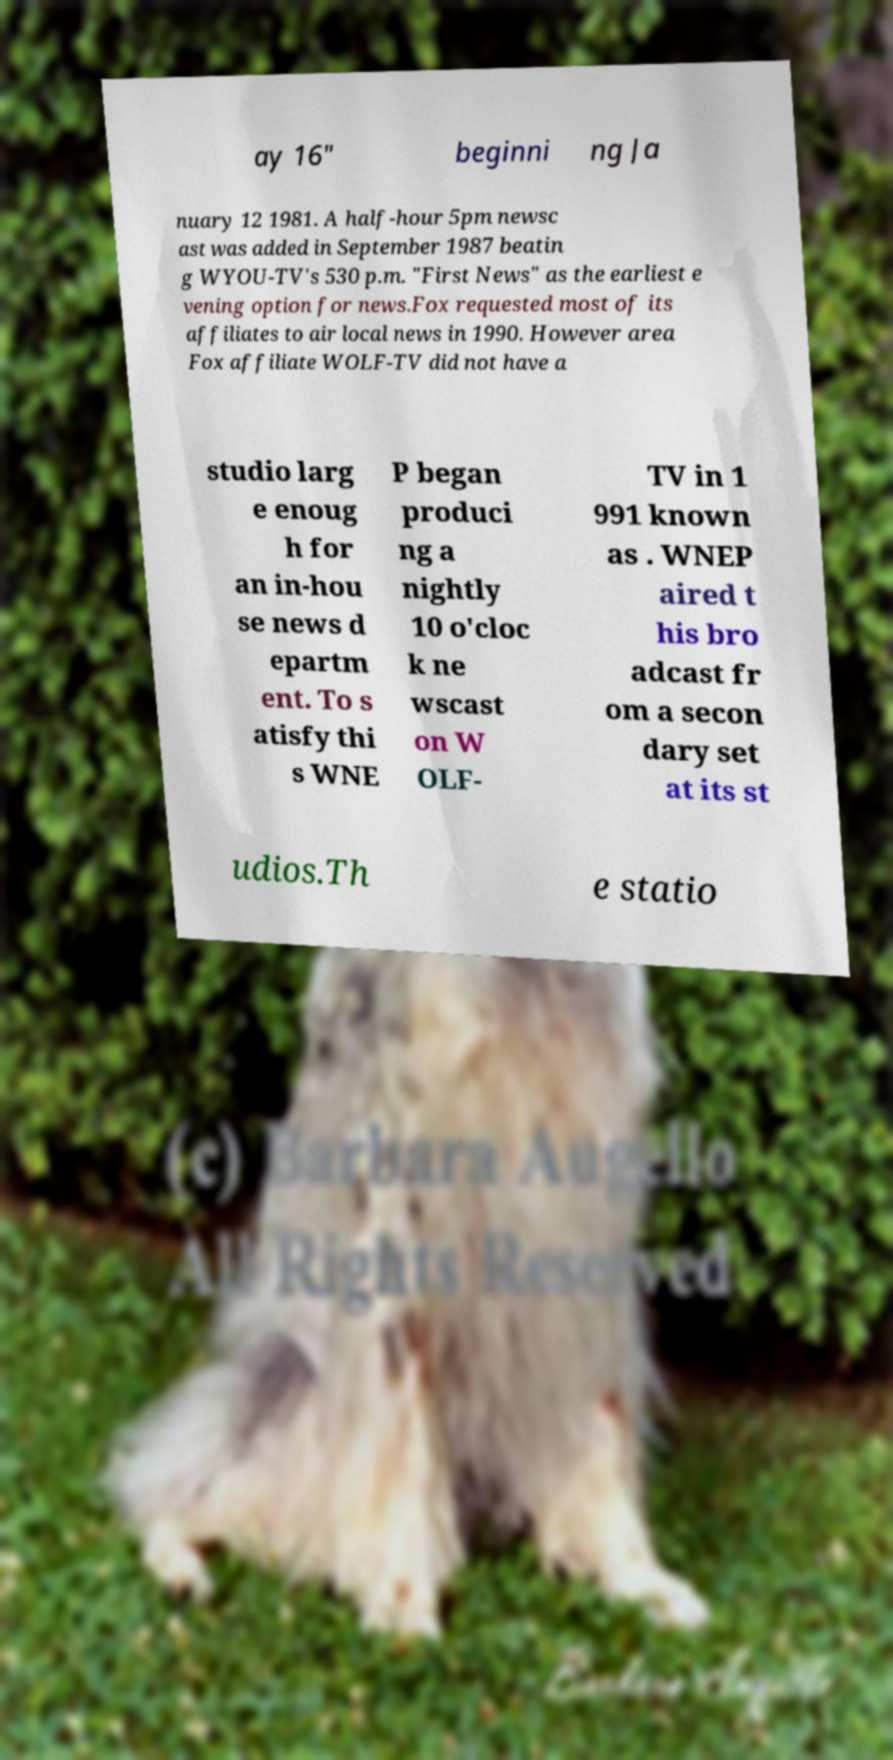For documentation purposes, I need the text within this image transcribed. Could you provide that? ay 16" beginni ng Ja nuary 12 1981. A half-hour 5pm newsc ast was added in September 1987 beatin g WYOU-TV's 530 p.m. "First News" as the earliest e vening option for news.Fox requested most of its affiliates to air local news in 1990. However area Fox affiliate WOLF-TV did not have a studio larg e enoug h for an in-hou se news d epartm ent. To s atisfy thi s WNE P began produci ng a nightly 10 o'cloc k ne wscast on W OLF- TV in 1 991 known as . WNEP aired t his bro adcast fr om a secon dary set at its st udios.Th e statio 